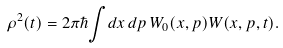<formula> <loc_0><loc_0><loc_500><loc_500>\rho ^ { 2 } ( t ) = 2 \pi \hbar { \int } d x \, d p \, W _ { 0 } ( x , p ) W ( x , p , t ) .</formula> 